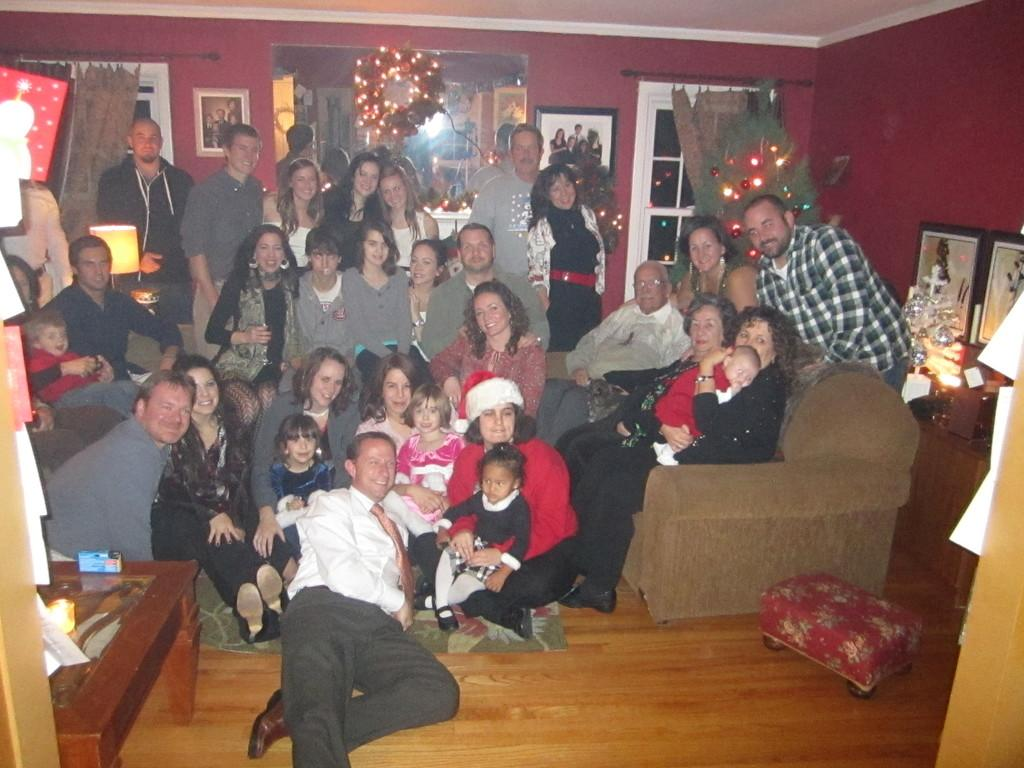How many people are in the image? There is a group of people in the image, but the exact number is not specified. What are the people in the image doing? Some people are seated, while others are standing. What can be seen on the wall in the image? There are photo frames and a poster on the wall. What is the Christmas tree's location in the image? The Christmas tree is in the image. What type of furniture is present in the image? There is a table in the image. What type of wrench is being used by the person in the image? There is no wrench present in the image. How many toes are visible on the person's feet in the image? The image does not show any visible toes on people's feet. 